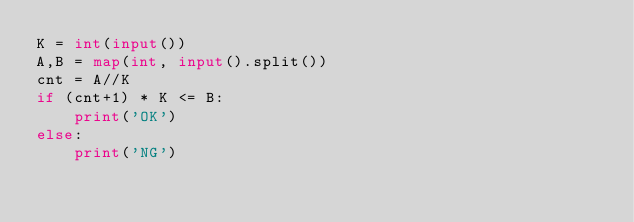Convert code to text. <code><loc_0><loc_0><loc_500><loc_500><_Python_>K = int(input())
A,B = map(int, input().split())
cnt = A//K
if (cnt+1) * K <= B:
    print('OK')
else:
    print('NG')</code> 